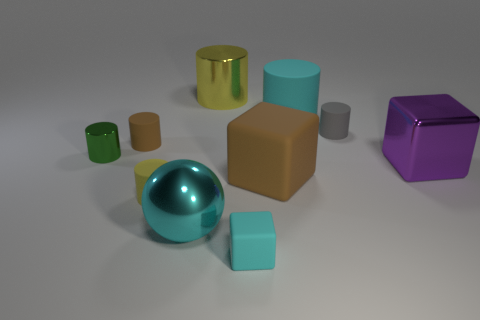There is a cyan shiny object; is it the same size as the cyan matte object that is in front of the tiny brown object?
Ensure brevity in your answer.  No. How many other things are there of the same color as the big matte cylinder?
Provide a short and direct response. 2. Are there more big cyan rubber things that are in front of the small gray rubber thing than tiny metal cylinders?
Offer a terse response. No. There is a big matte object in front of the shiny thing that is right of the yellow metal cylinder behind the large rubber cube; what color is it?
Give a very brief answer. Brown. Are the large purple object and the small cyan block made of the same material?
Offer a very short reply. No. Is there a yellow matte cylinder of the same size as the green cylinder?
Your answer should be compact. Yes. What is the material of the gray thing that is the same size as the green metal object?
Your response must be concise. Rubber. Is there a metallic thing that has the same shape as the big brown rubber object?
Offer a terse response. Yes. There is a cube that is the same color as the sphere; what material is it?
Your answer should be very brief. Rubber. The yellow object that is behind the yellow rubber cylinder has what shape?
Your answer should be compact. Cylinder. 